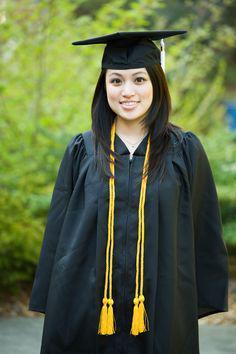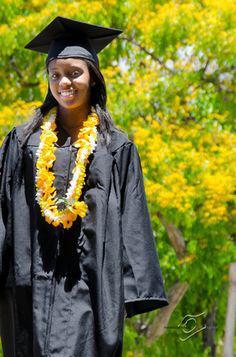The first image is the image on the left, the second image is the image on the right. Given the left and right images, does the statement "There is exactly one person in cap and gown in the right image." hold true? Answer yes or no. Yes. 